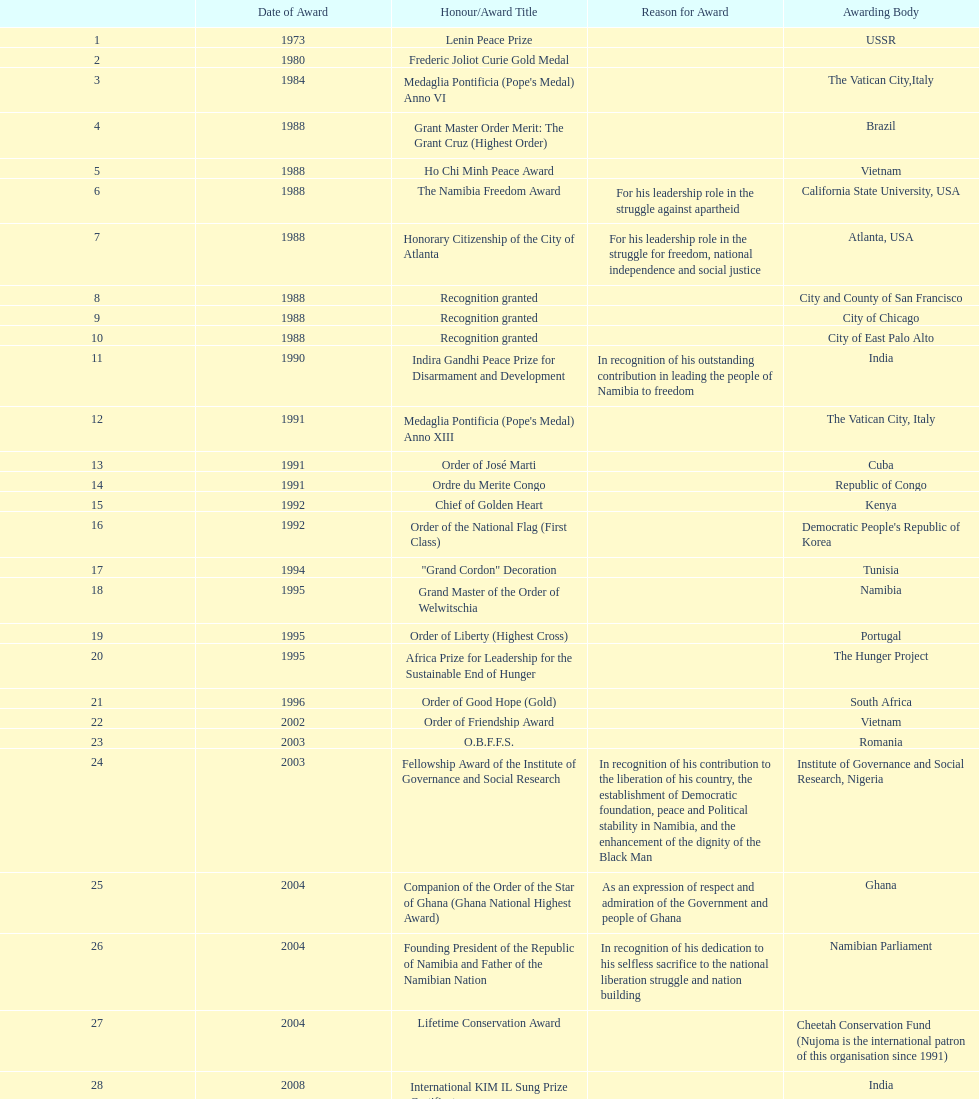The "fellowship award of the institute of governance and social research" was awarded in 2003 or 2004? 2003. 